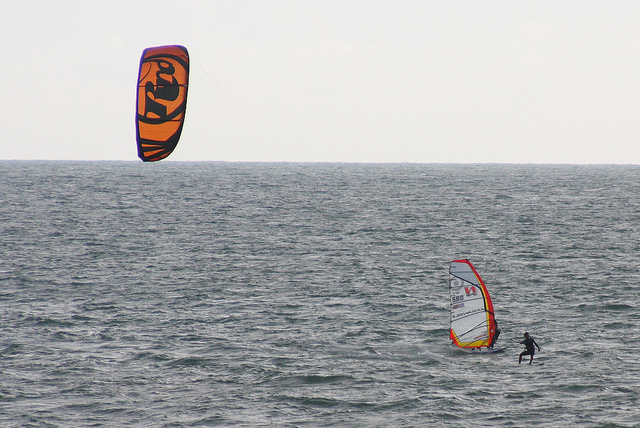What is this photo about? The photo captures a dynamic ocean scene where two water sports are being showcased. To the left, a vibrant and eye-catching orange parasail with unique markings catches the wind and soars above the sea. On the right side of the photo, a person, clad in a wetsuit, is skillfully windsurfing, maneuvering a board topped with a large sail through the waves. Nearby, another individual, also in a wetsuit, is present, adding to the action-packed atmosphere of the scene. 